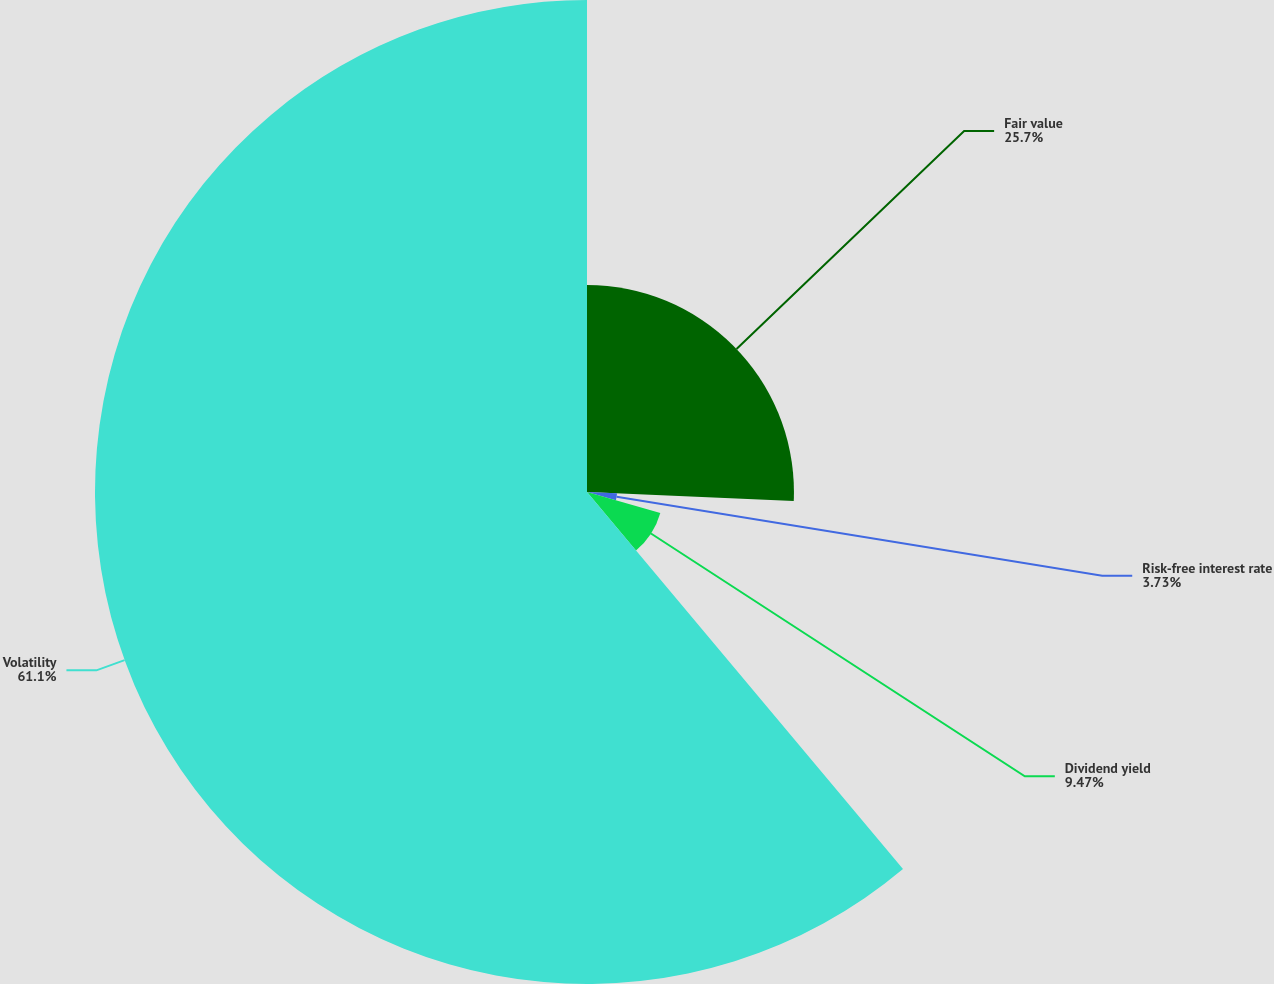<chart> <loc_0><loc_0><loc_500><loc_500><pie_chart><fcel>Fair value<fcel>Risk-free interest rate<fcel>Dividend yield<fcel>Volatility<nl><fcel>25.7%<fcel>3.73%<fcel>9.47%<fcel>61.1%<nl></chart> 